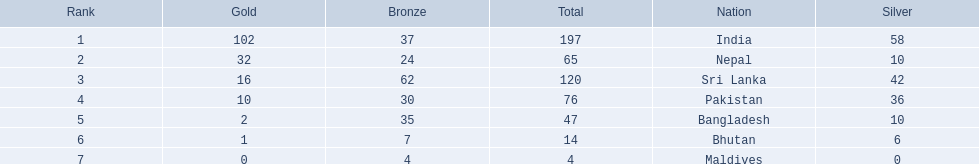What countries attended the 1999 south asian games? India, Nepal, Sri Lanka, Pakistan, Bangladesh, Bhutan, Maldives. Which of these countries had 32 gold medals? Nepal. 